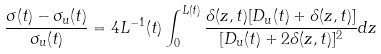Convert formula to latex. <formula><loc_0><loc_0><loc_500><loc_500>\frac { \sigma ( t ) - \sigma _ { u } ( t ) } { \sigma _ { u } ( t ) } = 4 L ^ { - 1 } ( t ) \int _ { 0 } ^ { L ( t ) } \frac { \delta ( z , t ) [ D _ { u } ( t ) + \delta ( z , t ) ] } { [ D _ { u } ( t ) + 2 \delta ( z , t ) ] ^ { 2 } } d z</formula> 